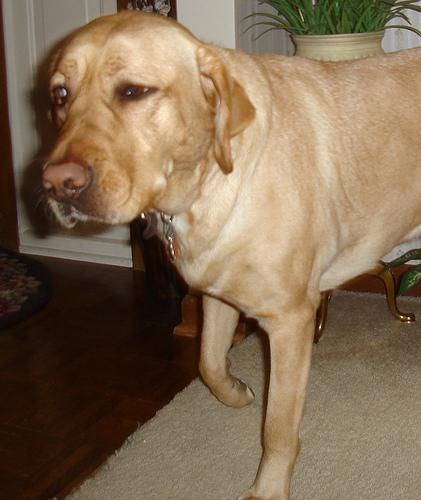Question: what color is the dog?
Choices:
A. Teal.
B. Purple.
C. Tan.
D. Tangerine.
Answer with the letter. Answer: C Question: where was this picture taken?
Choices:
A. Den.
B. Family room.
C. Living room.
D. Play room.
Answer with the letter. Answer: C Question: what is behind the dog?
Choices:
A. A plant.
B. Grass.
C. A garden.
D. Flowers.
Answer with the letter. Answer: A 